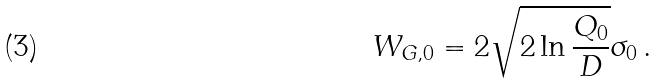Convert formula to latex. <formula><loc_0><loc_0><loc_500><loc_500>W _ { G , 0 } = 2 \sqrt { 2 \ln { \frac { Q _ { 0 } } { D } } } \sigma _ { 0 } \, .</formula> 